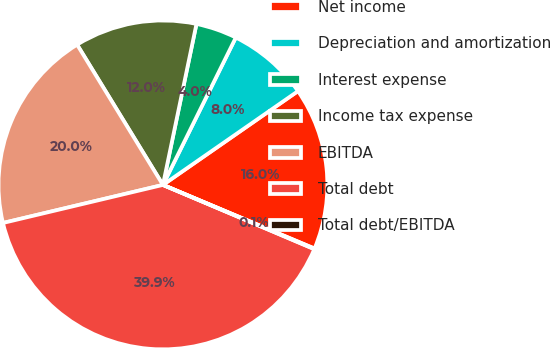Convert chart. <chart><loc_0><loc_0><loc_500><loc_500><pie_chart><fcel>Net income<fcel>Depreciation and amortization<fcel>Interest expense<fcel>Income tax expense<fcel>EBITDA<fcel>Total debt<fcel>Total debt/EBITDA<nl><fcel>15.99%<fcel>8.03%<fcel>4.04%<fcel>12.01%<fcel>19.98%<fcel>39.9%<fcel>0.06%<nl></chart> 